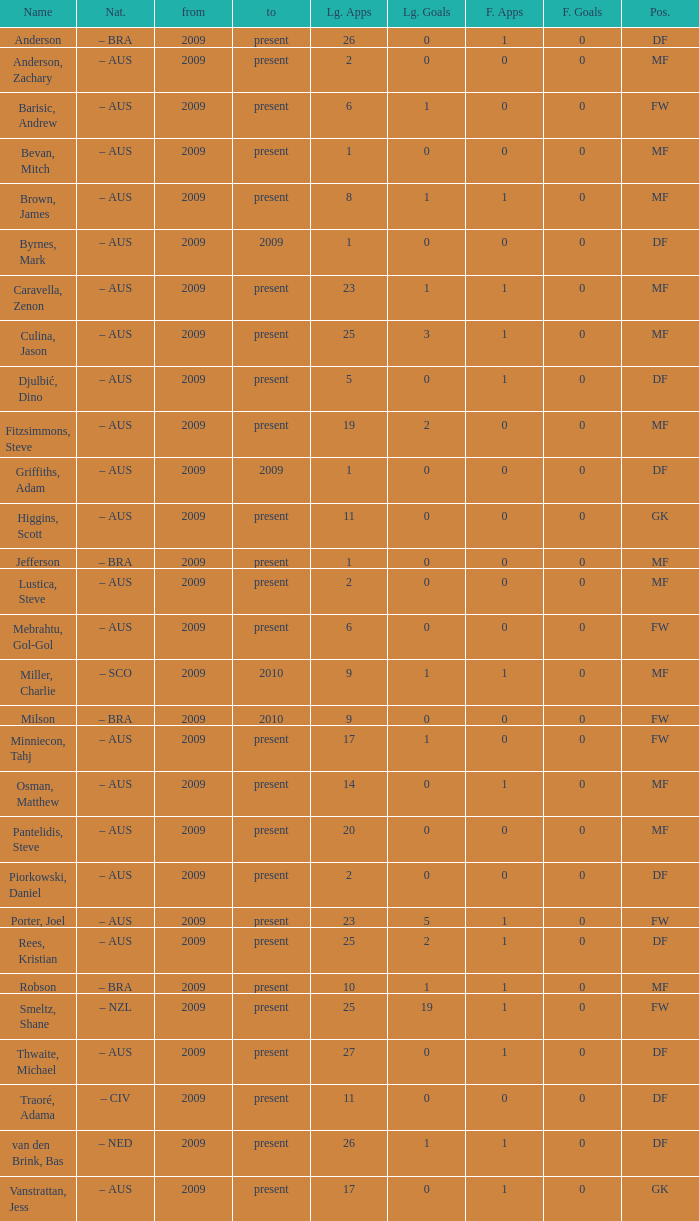Determine the post for van den brink, bas DF. 